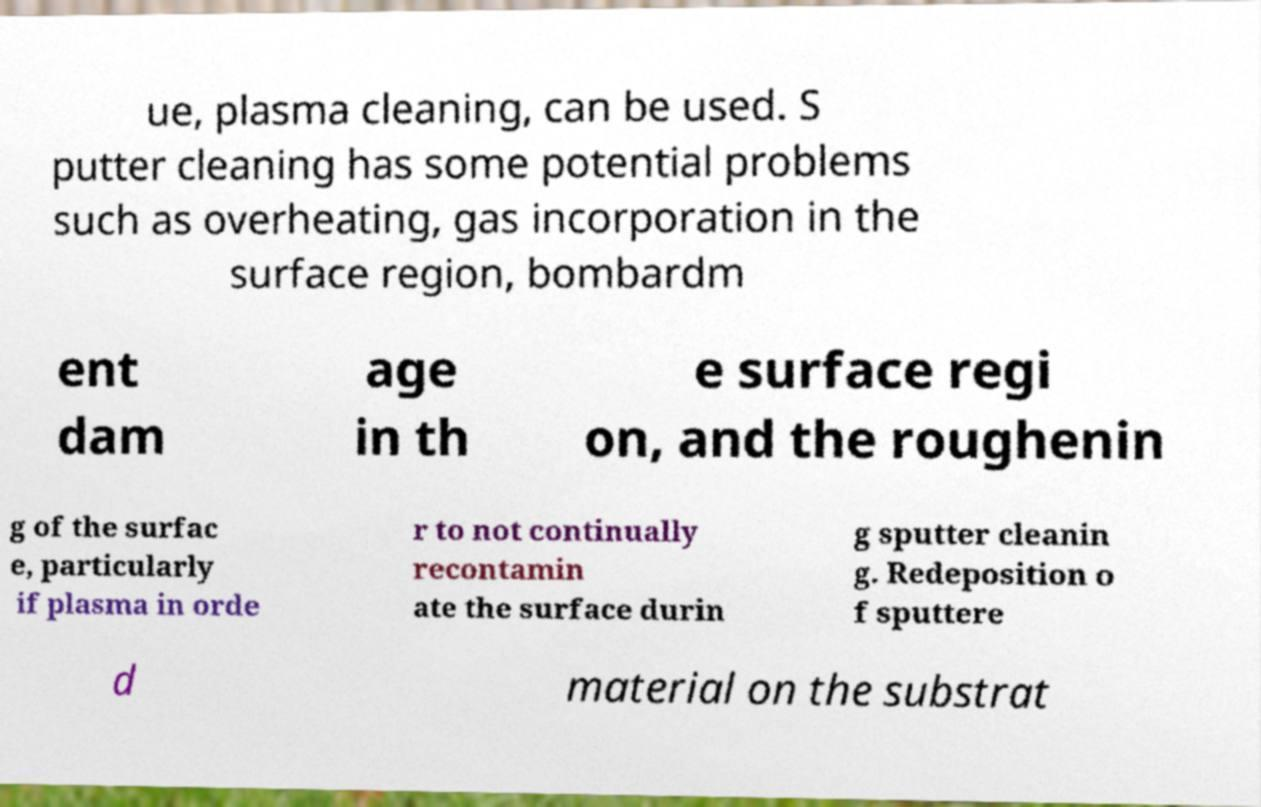Can you accurately transcribe the text from the provided image for me? ue, plasma cleaning, can be used. S putter cleaning has some potential problems such as overheating, gas incorporation in the surface region, bombardm ent dam age in th e surface regi on, and the roughenin g of the surfac e, particularly if plasma in orde r to not continually recontamin ate the surface durin g sputter cleanin g. Redeposition o f sputtere d material on the substrat 